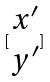Convert formula to latex. <formula><loc_0><loc_0><loc_500><loc_500>[ \begin{matrix} x ^ { \prime } \\ y ^ { \prime } \end{matrix} ]</formula> 